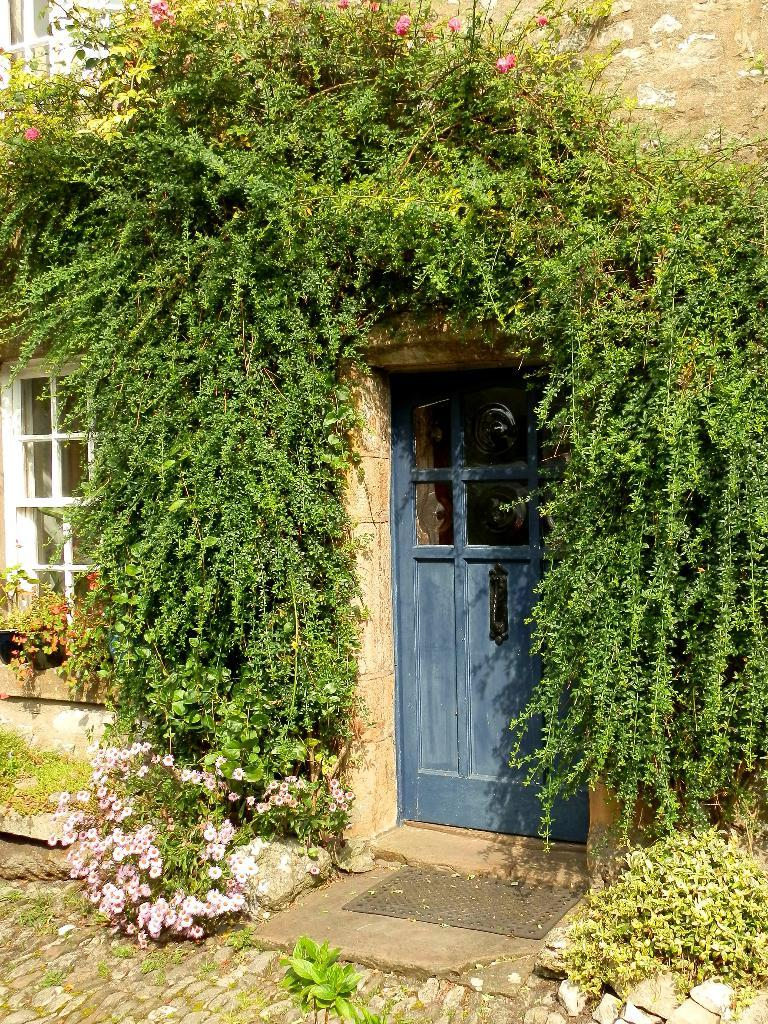What is the main subject of the image? The image depicts a building. What type of vegetation is present on the building? There are creepers and plants on the building. Are there any flowers on the building? Yes, there are flowers on the building. What architectural features can be seen on the building? The building has windows and a door. What is present on the ground at the bottom of the image? Rocks and a mat are present on the ground. Can you tell me how many times the person is raking the leaves in the image? There is no person or rake present in the image; it only features a building with vegetation and a ground with rocks and a mat. What type of hair can be seen on the person in the image? There is no person present in the image, so no hair can be observed. 